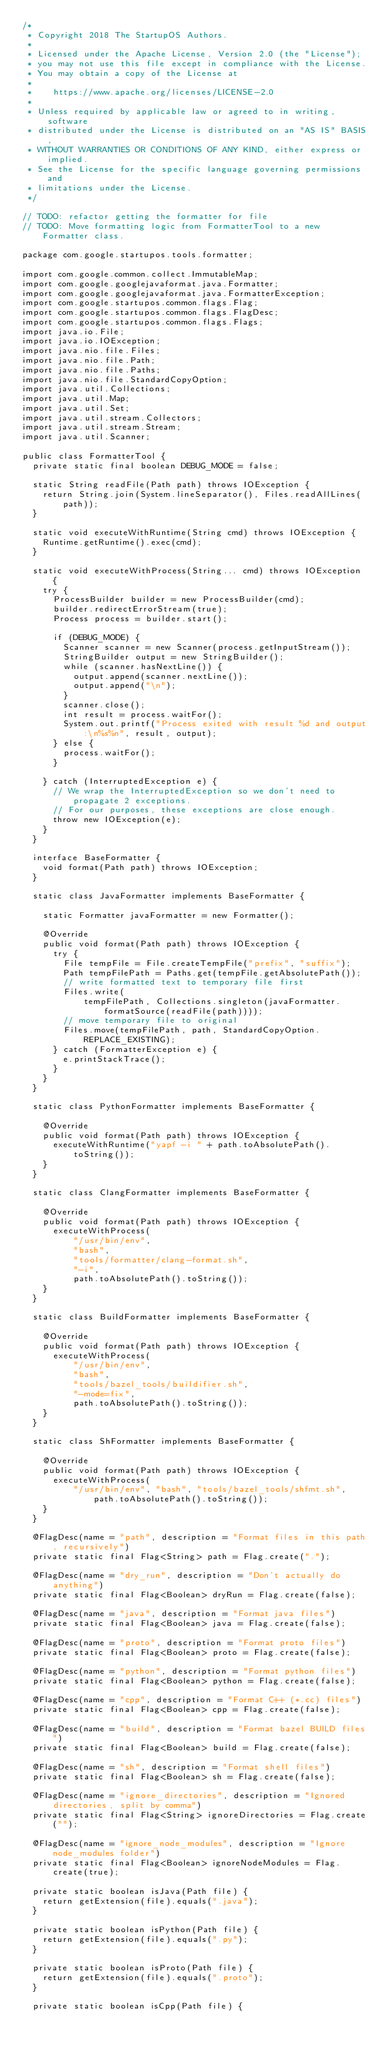<code> <loc_0><loc_0><loc_500><loc_500><_Java_>/*
 * Copyright 2018 The StartupOS Authors.
 *
 * Licensed under the Apache License, Version 2.0 (the "License");
 * you may not use this file except in compliance with the License.
 * You may obtain a copy of the License at
 *
 *    https://www.apache.org/licenses/LICENSE-2.0
 *
 * Unless required by applicable law or agreed to in writing, software
 * distributed under the License is distributed on an "AS IS" BASIS,
 * WITHOUT WARRANTIES OR CONDITIONS OF ANY KIND, either express or implied.
 * See the License for the specific language governing permissions and
 * limitations under the License.
 */

// TODO: refactor getting the formatter for file
// TODO: Move formatting logic from FormatterTool to a new Formatter class.

package com.google.startupos.tools.formatter;

import com.google.common.collect.ImmutableMap;
import com.google.googlejavaformat.java.Formatter;
import com.google.googlejavaformat.java.FormatterException;
import com.google.startupos.common.flags.Flag;
import com.google.startupos.common.flags.FlagDesc;
import com.google.startupos.common.flags.Flags;
import java.io.File;
import java.io.IOException;
import java.nio.file.Files;
import java.nio.file.Path;
import java.nio.file.Paths;
import java.nio.file.StandardCopyOption;
import java.util.Collections;
import java.util.Map;
import java.util.Set;
import java.util.stream.Collectors;
import java.util.stream.Stream;
import java.util.Scanner;

public class FormatterTool {
  private static final boolean DEBUG_MODE = false;

  static String readFile(Path path) throws IOException {
    return String.join(System.lineSeparator(), Files.readAllLines(path));
  }

  static void executeWithRuntime(String cmd) throws IOException {
    Runtime.getRuntime().exec(cmd);
  }

  static void executeWithProcess(String... cmd) throws IOException {
    try {
      ProcessBuilder builder = new ProcessBuilder(cmd);
      builder.redirectErrorStream(true);
      Process process = builder.start();

      if (DEBUG_MODE) {
        Scanner scanner = new Scanner(process.getInputStream());
        StringBuilder output = new StringBuilder();
        while (scanner.hasNextLine()) {
          output.append(scanner.nextLine());
          output.append("\n");
        }
        scanner.close();
        int result = process.waitFor();
        System.out.printf("Process exited with result %d and output:\n%s%n", result, output);
      } else {
        process.waitFor();
      }

    } catch (InterruptedException e) {
      // We wrap the InterruptedException so we don't need to propagate 2 exceptions.
      // For our purposes, these exceptions are close enough.
      throw new IOException(e);
    }
  }

  interface BaseFormatter {
    void format(Path path) throws IOException;
  }

  static class JavaFormatter implements BaseFormatter {

    static Formatter javaFormatter = new Formatter();

    @Override
    public void format(Path path) throws IOException {
      try {
        File tempFile = File.createTempFile("prefix", "suffix");
        Path tempFilePath = Paths.get(tempFile.getAbsolutePath());
        // write formatted text to temporary file first
        Files.write(
            tempFilePath, Collections.singleton(javaFormatter.formatSource(readFile(path))));
        // move temporary file to original
        Files.move(tempFilePath, path, StandardCopyOption.REPLACE_EXISTING);
      } catch (FormatterException e) {
        e.printStackTrace();
      }
    }
  }

  static class PythonFormatter implements BaseFormatter {

    @Override
    public void format(Path path) throws IOException {
      executeWithRuntime("yapf -i " + path.toAbsolutePath().toString());
    }
  }

  static class ClangFormatter implements BaseFormatter {

    @Override
    public void format(Path path) throws IOException {
      executeWithProcess(
          "/usr/bin/env",
          "bash",
          "tools/formatter/clang-format.sh",
          "-i",
          path.toAbsolutePath().toString());
    }
  }

  static class BuildFormatter implements BaseFormatter {

    @Override
    public void format(Path path) throws IOException {
      executeWithProcess(
          "/usr/bin/env",
          "bash",
          "tools/bazel_tools/buildifier.sh",
          "-mode=fix",
          path.toAbsolutePath().toString());
    }
  }

  static class ShFormatter implements BaseFormatter {

    @Override
    public void format(Path path) throws IOException {
      executeWithProcess(
          "/usr/bin/env", "bash", "tools/bazel_tools/shfmt.sh", path.toAbsolutePath().toString());
    }
  }

  @FlagDesc(name = "path", description = "Format files in this path, recursively")
  private static final Flag<String> path = Flag.create(".");

  @FlagDesc(name = "dry_run", description = "Don't actually do anything")
  private static final Flag<Boolean> dryRun = Flag.create(false);

  @FlagDesc(name = "java", description = "Format java files")
  private static final Flag<Boolean> java = Flag.create(false);

  @FlagDesc(name = "proto", description = "Format proto files")
  private static final Flag<Boolean> proto = Flag.create(false);

  @FlagDesc(name = "python", description = "Format python files")
  private static final Flag<Boolean> python = Flag.create(false);

  @FlagDesc(name = "cpp", description = "Format C++ (*.cc) files")
  private static final Flag<Boolean> cpp = Flag.create(false);

  @FlagDesc(name = "build", description = "Format bazel BUILD files")
  private static final Flag<Boolean> build = Flag.create(false);

  @FlagDesc(name = "sh", description = "Format shell files")
  private static final Flag<Boolean> sh = Flag.create(false);

  @FlagDesc(name = "ignore_directories", description = "Ignored directories, split by comma")
  private static final Flag<String> ignoreDirectories = Flag.create("");

  @FlagDesc(name = "ignore_node_modules", description = "Ignore node_modules folder")
  private static final Flag<Boolean> ignoreNodeModules = Flag.create(true);

  private static boolean isJava(Path file) {
    return getExtension(file).equals(".java");
  }

  private static boolean isPython(Path file) {
    return getExtension(file).equals(".py");
  }

  private static boolean isProto(Path file) {
    return getExtension(file).equals(".proto");
  }

  private static boolean isCpp(Path file) {</code> 